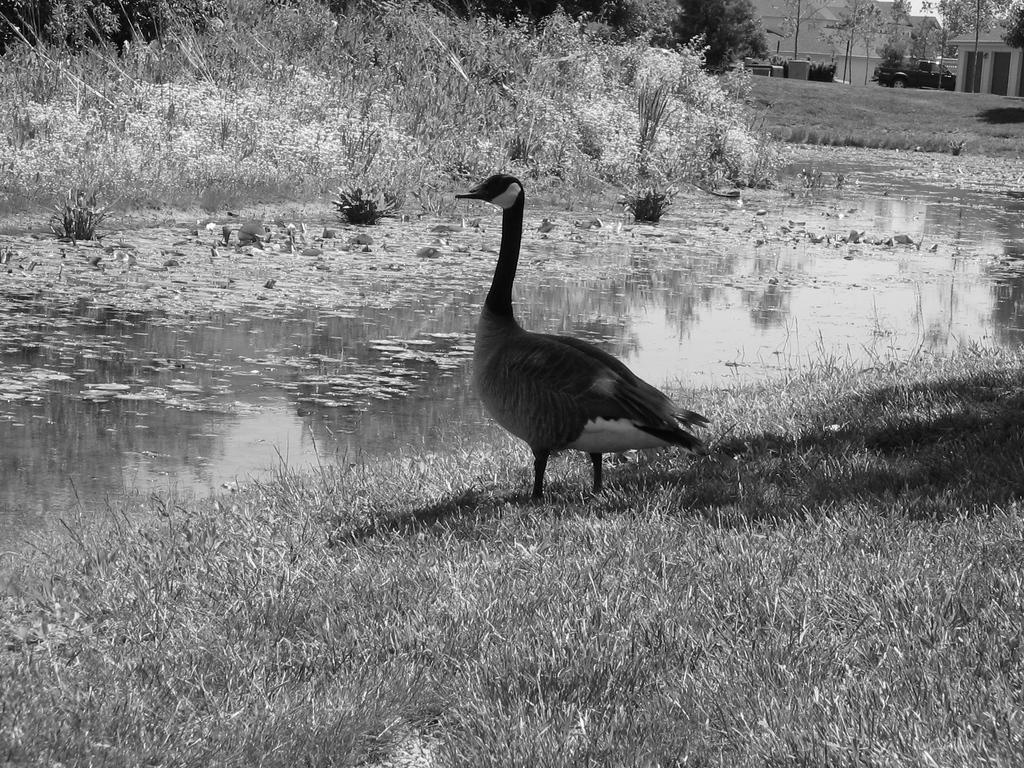What animal can be seen in the image? There is a duck standing on the grass in the image. What can be seen in the background of the image? Water, plants, buildings, and trees are visible in the background of the image. What type of transportation is present in the background? There is a vehicle in the background. How many jellyfish can be seen swimming in the water in the image? There are no jellyfish present in the image; it features a duck standing on the grass and various background elements. 